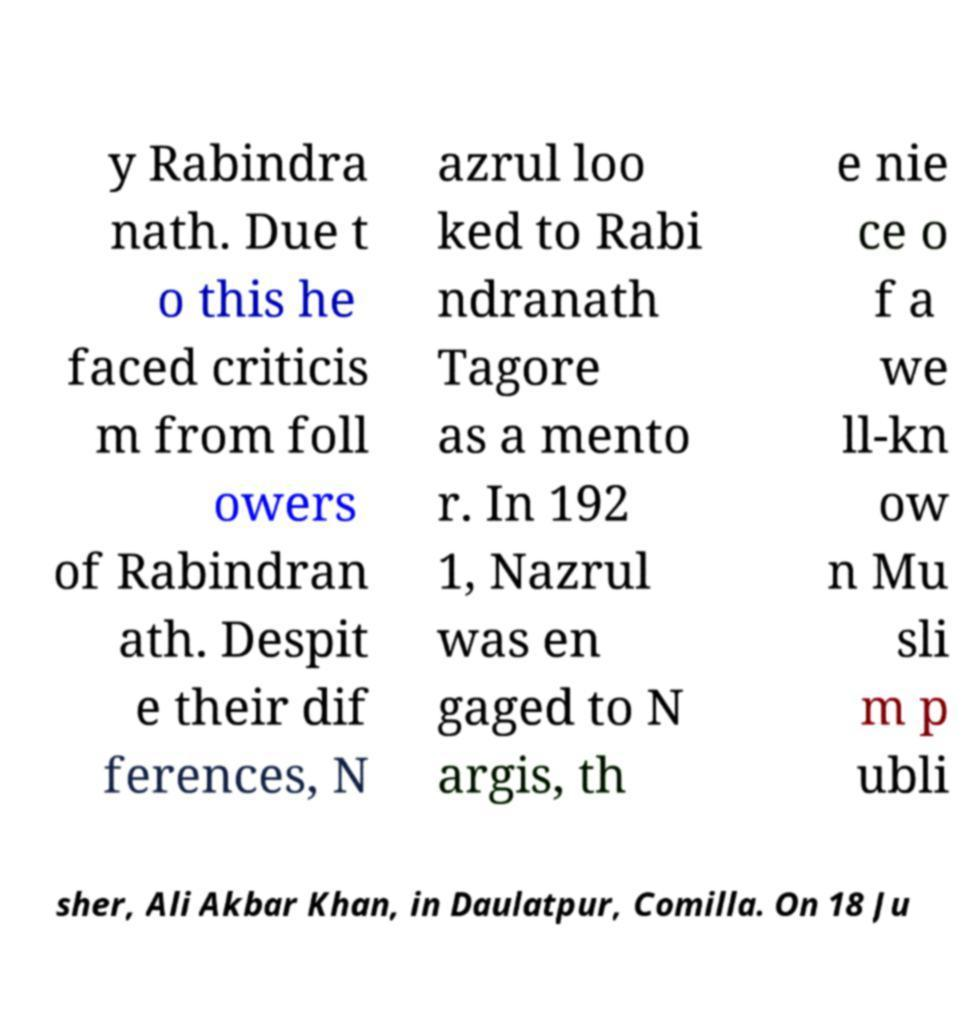Please identify and transcribe the text found in this image. y Rabindra nath. Due t o this he faced criticis m from foll owers of Rabindran ath. Despit e their dif ferences, N azrul loo ked to Rabi ndranath Tagore as a mento r. In 192 1, Nazrul was en gaged to N argis, th e nie ce o f a we ll-kn ow n Mu sli m p ubli sher, Ali Akbar Khan, in Daulatpur, Comilla. On 18 Ju 